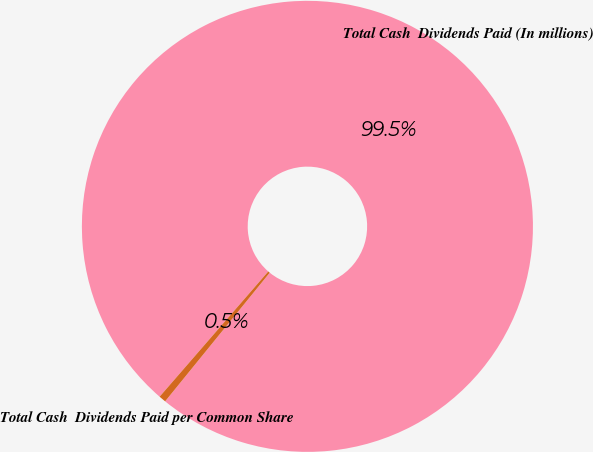Convert chart to OTSL. <chart><loc_0><loc_0><loc_500><loc_500><pie_chart><fcel>Total Cash  Dividends Paid (In millions)<fcel>Total Cash  Dividends Paid per Common Share<nl><fcel>99.49%<fcel>0.51%<nl></chart> 